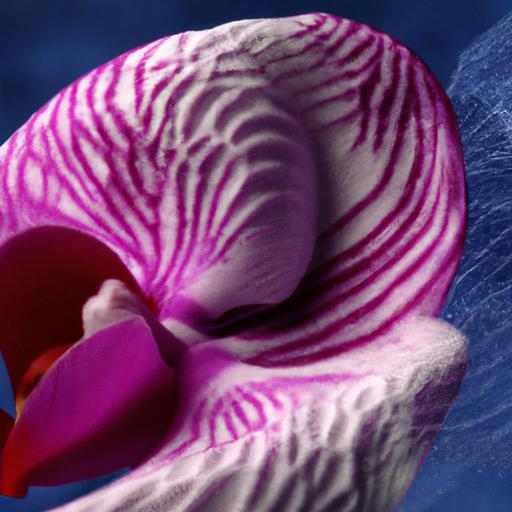What type of flower is shown in the image? The image showcases an orchid, identifiable by its distinct symmetry, vibrant colors, and unique patterns on the petals that resemble veins. 